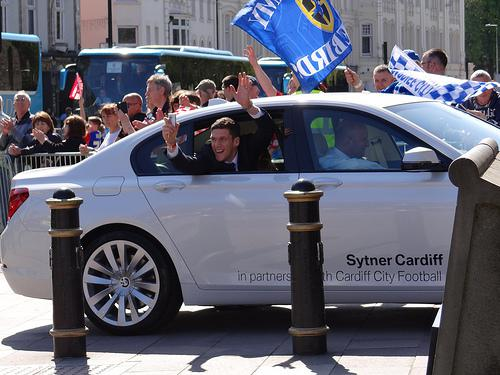Question: how many cars are there?
Choices:
A. 1.
B. 3.
C. 4.
D. 5.
Answer with the letter. Answer: A Question: what name is on the car?
Choices:
A. Sytner Cardiff.
B. Jeff Gordan.
C. Shelby.
D. Findley Toyota.
Answer with the letter. Answer: A Question: what is the crowd standing behind?
Choices:
A. A metal barricade.
B. A fence.
C. Rope.
D. Cement girders.
Answer with the letter. Answer: A 